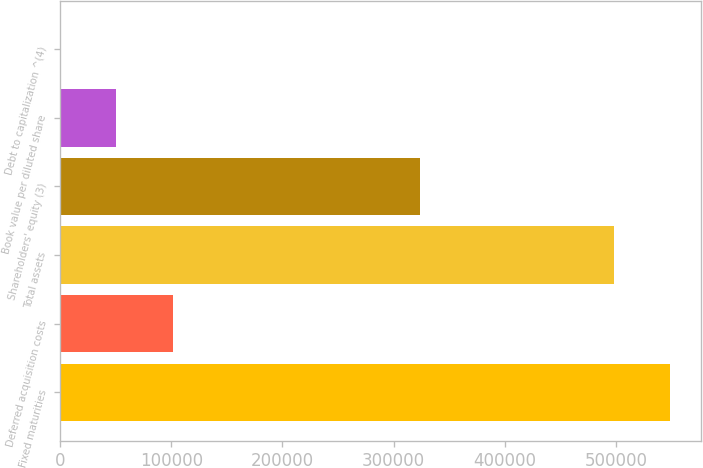Convert chart. <chart><loc_0><loc_0><loc_500><loc_500><bar_chart><fcel>Fixed maturities<fcel>Deferred acquisition costs<fcel>Total assets<fcel>Shareholders' equity (3)<fcel>Book value per diluted share<fcel>Debt to capitalization ^(4)<nl><fcel>548899<fcel>101232<fcel>498284<fcel>323885<fcel>50616.7<fcel>1.5<nl></chart> 